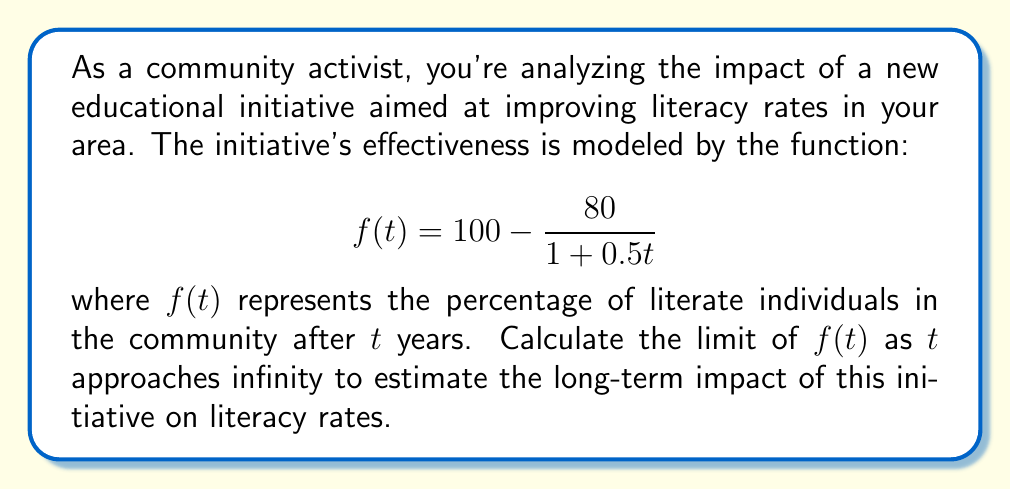Could you help me with this problem? To solve this problem, we need to evaluate the limit of $f(t)$ as $t$ approaches infinity. Let's break it down step by step:

1) First, let's recall the given function:

   $$f(t) = 100 - \frac{80}{1 + 0.5t}$$

2) To find the limit as $t$ approaches infinity, we need to consider what happens to each part of the function:

   $$\lim_{t \to \infty} f(t) = \lim_{t \to \infty} \left(100 - \frac{80}{1 + 0.5t}\right)$$

3) The constant 100 remains unchanged as $t$ approaches infinity.

4) For the fraction $\frac{80}{1 + 0.5t}$, as $t$ gets very large, $0.5t$ also becomes very large. This means the denominator $(1 + 0.5t)$ grows infinitely large.

5) When a constant (80 in this case) is divided by an infinitely large number, the result approaches zero:

   $$\lim_{t \to \infty} \frac{80}{1 + 0.5t} = 0$$

6) Therefore, we can evaluate the limit:

   $$\lim_{t \to \infty} f(t) = \lim_{t \to \infty} \left(100 - \frac{80}{1 + 0.5t}\right) = 100 - 0 = 100$$

This means that as time goes on indefinitely, the literacy rate approaches 100%.
Answer: The limit of $f(t)$ as $t$ approaches infinity is 100, indicating that the long-term impact of the educational initiative is estimated to achieve a 100% literacy rate in the community. 